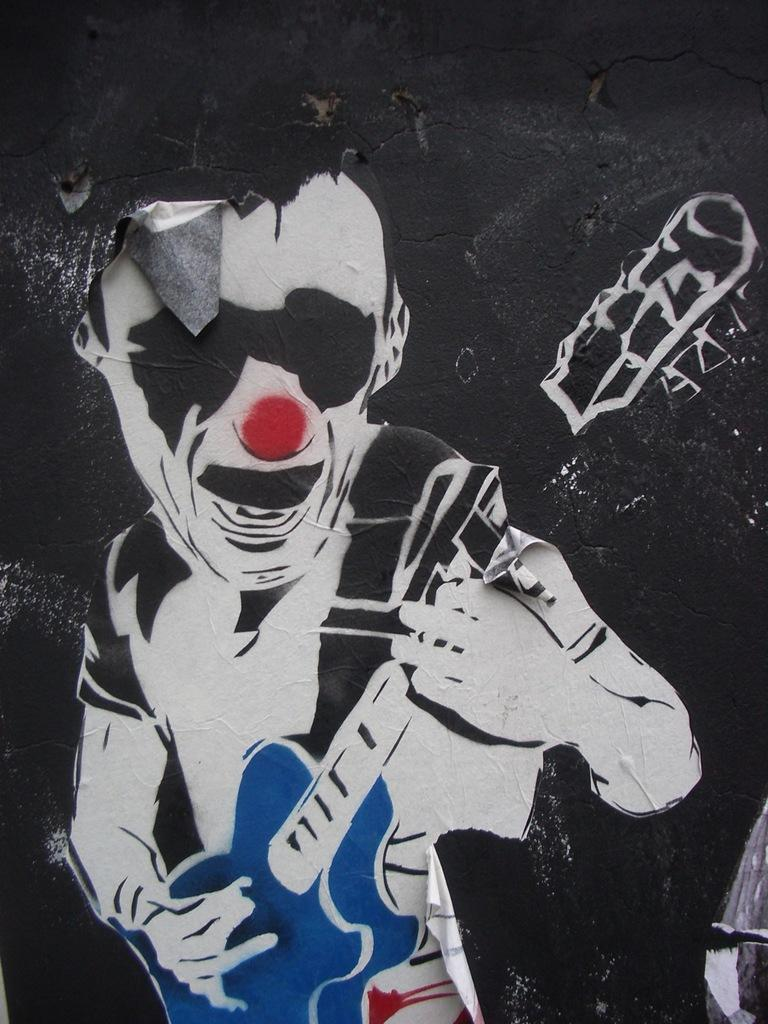What is featured on the poster in the image? The poster depicts a person playing a guitar. Where is the poster located in the image? The poster is on a wall. Can you tell me how many women are teaching in the image? There are no women teaching in the image, as the image only features a poster with a person playing a guitar on a wall. 